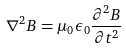Convert formula to latex. <formula><loc_0><loc_0><loc_500><loc_500>\nabla ^ { 2 } B = \mu _ { 0 } \epsilon _ { 0 } \frac { \partial ^ { 2 } B } { \partial t ^ { 2 } }</formula> 